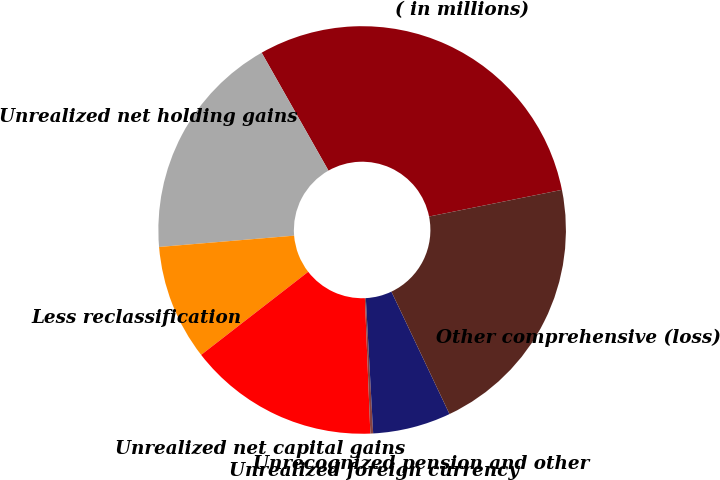Convert chart to OTSL. <chart><loc_0><loc_0><loc_500><loc_500><pie_chart><fcel>( in millions)<fcel>Unrealized net holding gains<fcel>Less reclassification<fcel>Unrealized net capital gains<fcel>Unrealized foreign currency<fcel>Unrecognized pension and other<fcel>Other comprehensive (loss)<nl><fcel>30.05%<fcel>18.12%<fcel>9.17%<fcel>15.14%<fcel>0.22%<fcel>6.19%<fcel>21.1%<nl></chart> 